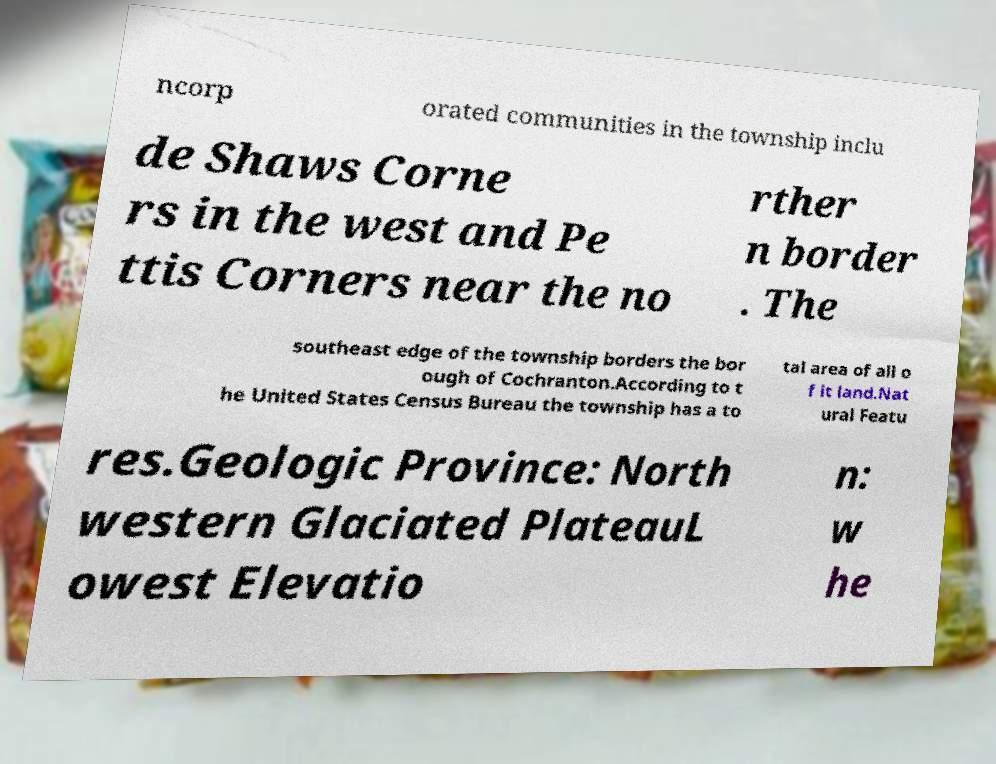Could you extract and type out the text from this image? ncorp orated communities in the township inclu de Shaws Corne rs in the west and Pe ttis Corners near the no rther n border . The southeast edge of the township borders the bor ough of Cochranton.According to t he United States Census Bureau the township has a to tal area of all o f it land.Nat ural Featu res.Geologic Province: North western Glaciated PlateauL owest Elevatio n: w he 